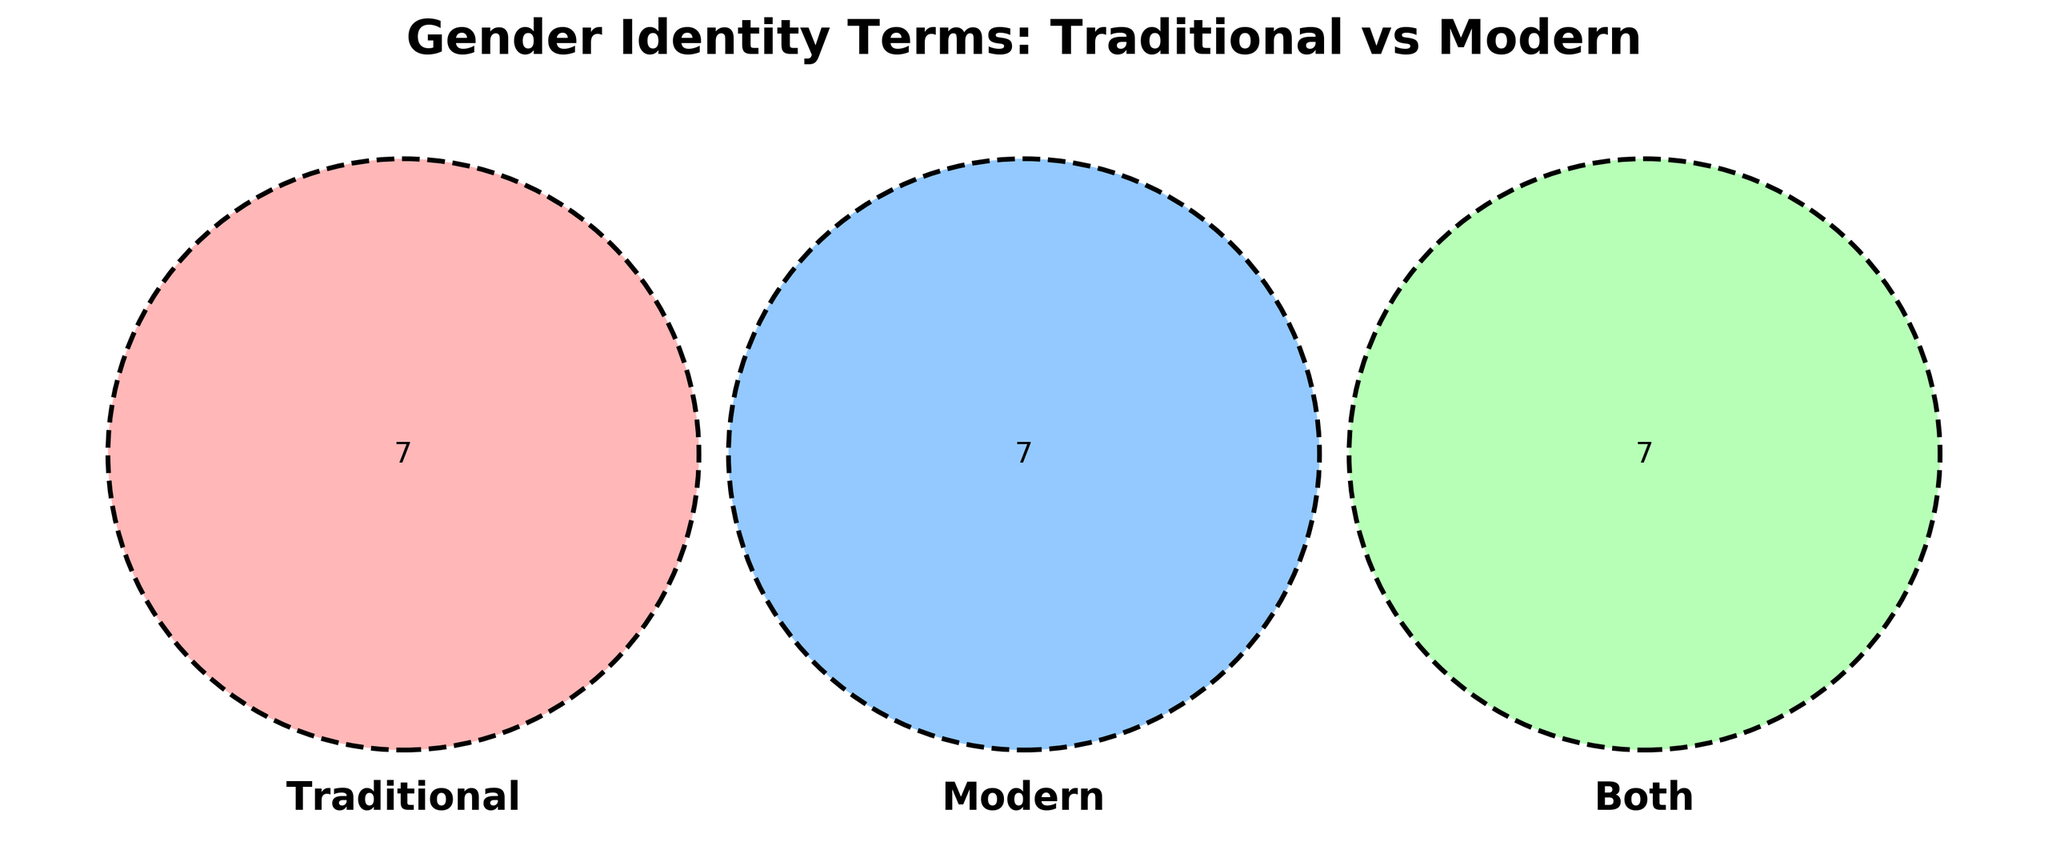What is the title of the figure? The title is located at the top of the figure and is meant to provide an overview of what the figure is about.
Answer: Gender Identity Terms: Traditional vs Modern What are the 3 sets represented in the Venn Diagram? The labels on the Venn Diagram show the sets being compared.
Answer: Traditional, Modern, Both Which terms are in the "Both" category? These terms are located in the intersection area of all three circles labeled "Both".
Answer: Transgender, Gender expression, Gender identity, Pronouns, Coming out, Gender dysphoria, Self-identification How many terms are unique to the "Traditional" category? Count the items in the area labeled "Traditional" that do not overlap with other circles.
Answer: 7 Which category contains the term "Non-binary"? Find the label "Non-binary" in one of the sectors of the Venn Diagram.
Answer: Modern What terms are common to both "Traditional" and "Both"? Look at the pairwise intersection between the "Traditional" and "Both" sets.
Answer: None Which category includes the term "Genderfluid"? Locate "Genderfluid" in the diagram to see which circle it appears in.
Answer: Modern Are there more terms in the "Both" category or the "Modern" category? Count the number of terms in the "Both" category and compare it to the "Modern" category.
Answer: Modern Which terms are found in the "Traditional" and "Both" areas but not in "Modern"? List all the terms that overlap between "Traditional" and "Both" without intersecting with "Modern".
Answer: None What is the relationship between "Traditional" terms and "Modern" terms? Terms exclusively in "Traditional" do not appear in "Modern" and vice versa; terms that appear in both categories are in the "Both" section.
Answer: Mutual exclusivity with overlapping through "Both" 